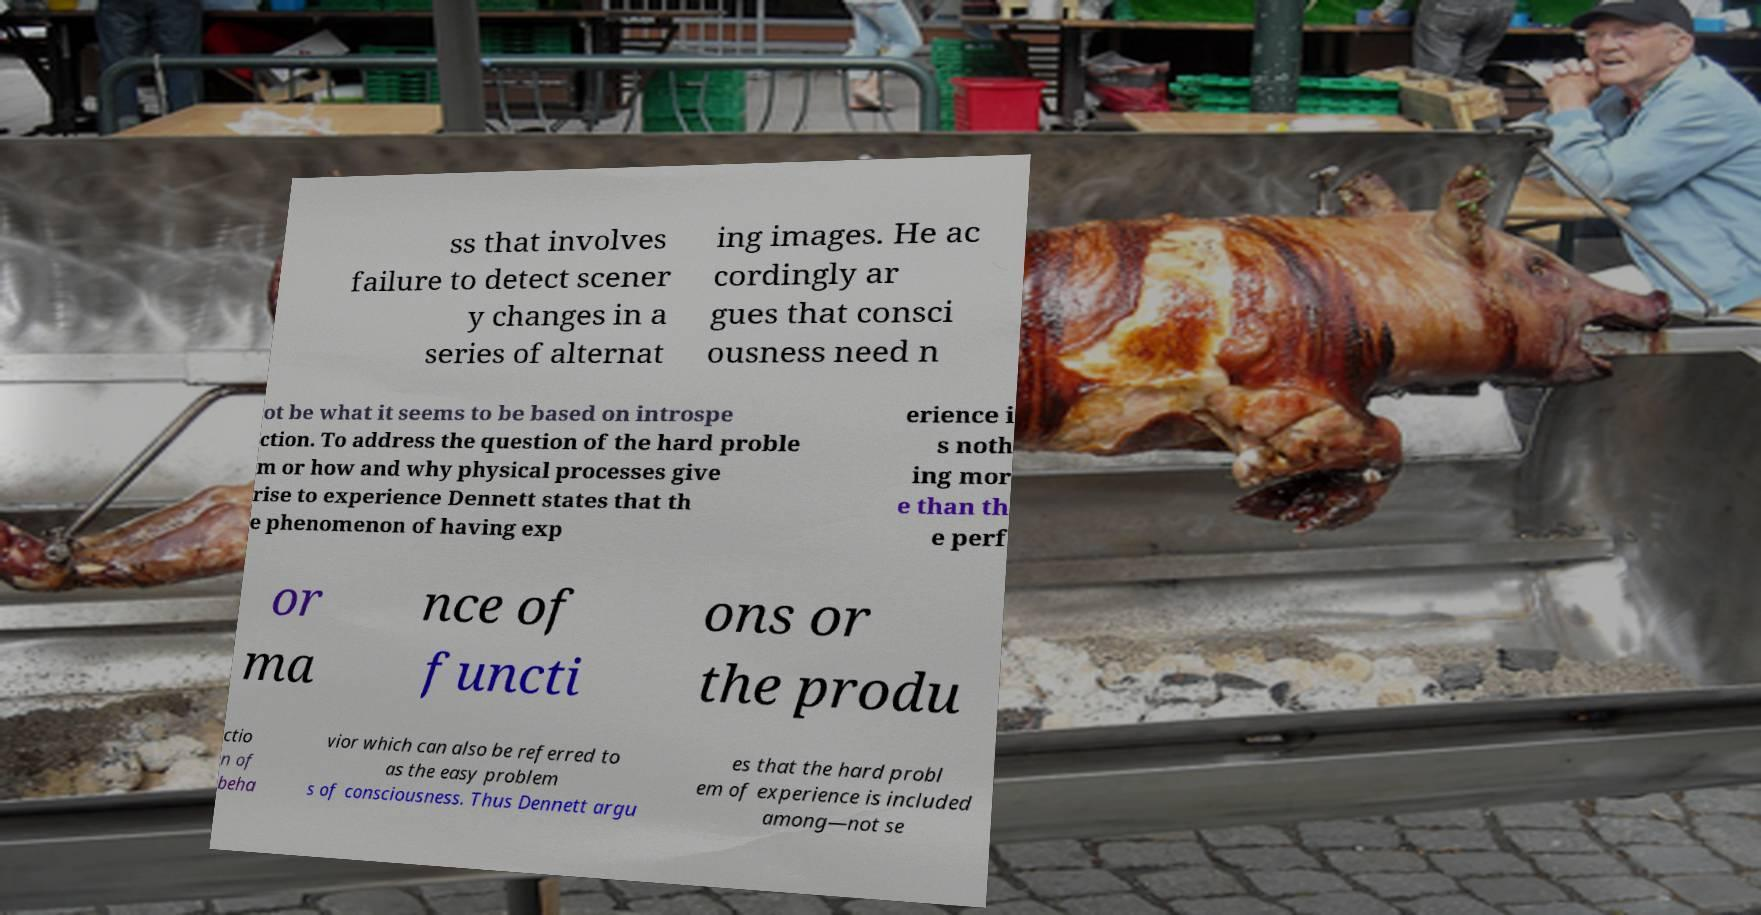Can you read and provide the text displayed in the image?This photo seems to have some interesting text. Can you extract and type it out for me? ss that involves failure to detect scener y changes in a series of alternat ing images. He ac cordingly ar gues that consci ousness need n ot be what it seems to be based on introspe ction. To address the question of the hard proble m or how and why physical processes give rise to experience Dennett states that th e phenomenon of having exp erience i s noth ing mor e than th e perf or ma nce of functi ons or the produ ctio n of beha vior which can also be referred to as the easy problem s of consciousness. Thus Dennett argu es that the hard probl em of experience is included among—not se 